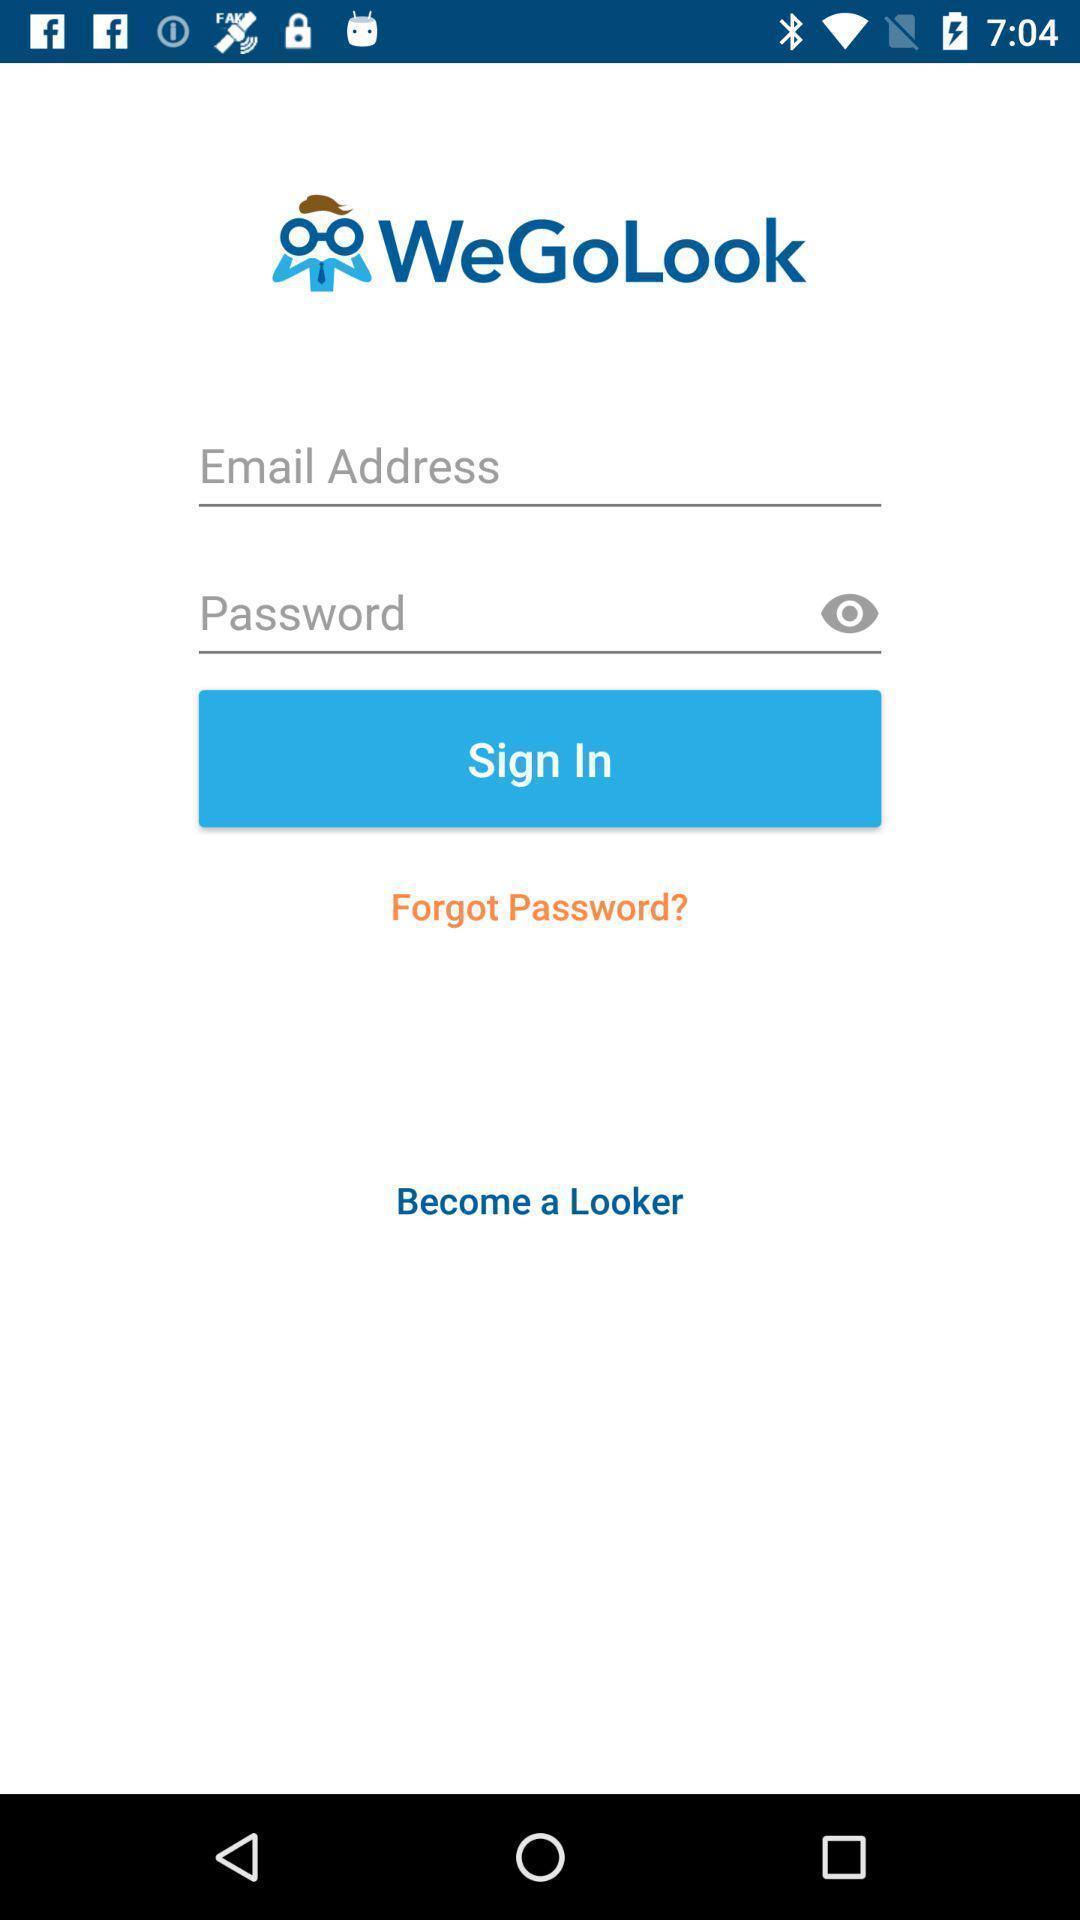Give me a summary of this screen capture. Welcome page. 